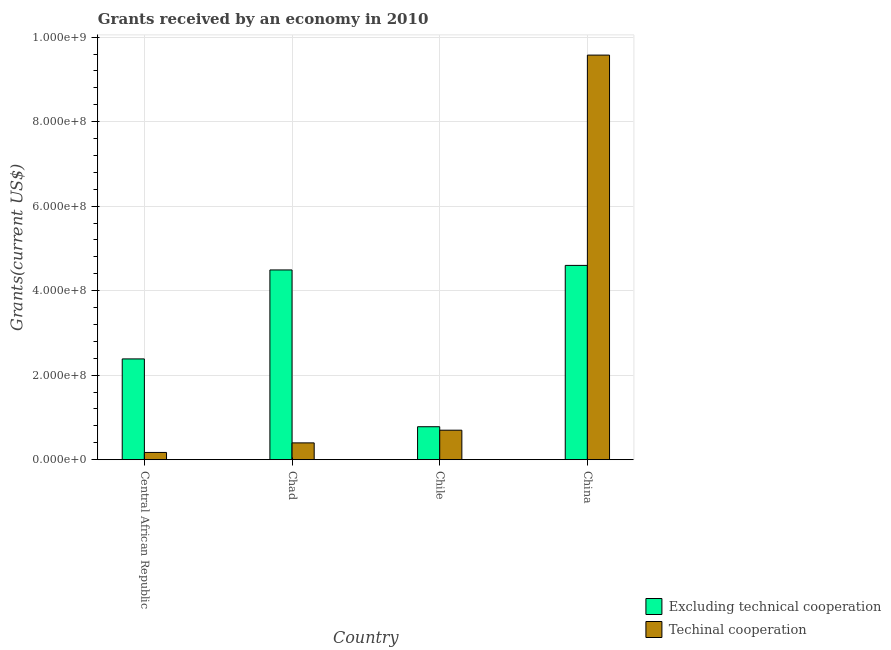How many different coloured bars are there?
Your response must be concise. 2. How many groups of bars are there?
Provide a short and direct response. 4. Are the number of bars per tick equal to the number of legend labels?
Provide a short and direct response. Yes. How many bars are there on the 3rd tick from the left?
Offer a very short reply. 2. What is the label of the 2nd group of bars from the left?
Keep it short and to the point. Chad. In how many cases, is the number of bars for a given country not equal to the number of legend labels?
Give a very brief answer. 0. What is the amount of grants received(including technical cooperation) in Central African Republic?
Provide a short and direct response. 1.72e+07. Across all countries, what is the maximum amount of grants received(excluding technical cooperation)?
Your answer should be very brief. 4.60e+08. Across all countries, what is the minimum amount of grants received(excluding technical cooperation)?
Your response must be concise. 7.80e+07. In which country was the amount of grants received(including technical cooperation) maximum?
Offer a terse response. China. In which country was the amount of grants received(including technical cooperation) minimum?
Your answer should be compact. Central African Republic. What is the total amount of grants received(excluding technical cooperation) in the graph?
Make the answer very short. 1.23e+09. What is the difference between the amount of grants received(excluding technical cooperation) in Central African Republic and that in Chile?
Provide a short and direct response. 1.60e+08. What is the difference between the amount of grants received(including technical cooperation) in China and the amount of grants received(excluding technical cooperation) in Chile?
Your response must be concise. 8.79e+08. What is the average amount of grants received(including technical cooperation) per country?
Your answer should be very brief. 2.71e+08. What is the difference between the amount of grants received(including technical cooperation) and amount of grants received(excluding technical cooperation) in Central African Republic?
Provide a succinct answer. -2.21e+08. In how many countries, is the amount of grants received(including technical cooperation) greater than 520000000 US$?
Your answer should be very brief. 1. What is the ratio of the amount of grants received(including technical cooperation) in Chad to that in Chile?
Your answer should be very brief. 0.57. Is the amount of grants received(excluding technical cooperation) in Chile less than that in China?
Your answer should be compact. Yes. Is the difference between the amount of grants received(including technical cooperation) in Central African Republic and China greater than the difference between the amount of grants received(excluding technical cooperation) in Central African Republic and China?
Make the answer very short. No. What is the difference between the highest and the second highest amount of grants received(including technical cooperation)?
Keep it short and to the point. 8.88e+08. What is the difference between the highest and the lowest amount of grants received(including technical cooperation)?
Your answer should be very brief. 9.40e+08. What does the 1st bar from the left in China represents?
Provide a succinct answer. Excluding technical cooperation. What does the 1st bar from the right in China represents?
Offer a terse response. Techinal cooperation. How many bars are there?
Make the answer very short. 8. How many countries are there in the graph?
Provide a succinct answer. 4. Are the values on the major ticks of Y-axis written in scientific E-notation?
Your answer should be very brief. Yes. How are the legend labels stacked?
Give a very brief answer. Vertical. What is the title of the graph?
Offer a terse response. Grants received by an economy in 2010. Does "Transport services" appear as one of the legend labels in the graph?
Keep it short and to the point. No. What is the label or title of the X-axis?
Keep it short and to the point. Country. What is the label or title of the Y-axis?
Offer a terse response. Grants(current US$). What is the Grants(current US$) of Excluding technical cooperation in Central African Republic?
Your response must be concise. 2.38e+08. What is the Grants(current US$) in Techinal cooperation in Central African Republic?
Keep it short and to the point. 1.72e+07. What is the Grants(current US$) of Excluding technical cooperation in Chad?
Offer a terse response. 4.49e+08. What is the Grants(current US$) in Techinal cooperation in Chad?
Make the answer very short. 3.98e+07. What is the Grants(current US$) of Excluding technical cooperation in Chile?
Provide a succinct answer. 7.80e+07. What is the Grants(current US$) in Techinal cooperation in Chile?
Offer a terse response. 6.98e+07. What is the Grants(current US$) of Excluding technical cooperation in China?
Your answer should be compact. 4.60e+08. What is the Grants(current US$) of Techinal cooperation in China?
Provide a succinct answer. 9.57e+08. Across all countries, what is the maximum Grants(current US$) of Excluding technical cooperation?
Offer a terse response. 4.60e+08. Across all countries, what is the maximum Grants(current US$) in Techinal cooperation?
Your answer should be very brief. 9.57e+08. Across all countries, what is the minimum Grants(current US$) of Excluding technical cooperation?
Your answer should be compact. 7.80e+07. Across all countries, what is the minimum Grants(current US$) in Techinal cooperation?
Provide a short and direct response. 1.72e+07. What is the total Grants(current US$) of Excluding technical cooperation in the graph?
Provide a succinct answer. 1.23e+09. What is the total Grants(current US$) in Techinal cooperation in the graph?
Keep it short and to the point. 1.08e+09. What is the difference between the Grants(current US$) in Excluding technical cooperation in Central African Republic and that in Chad?
Give a very brief answer. -2.11e+08. What is the difference between the Grants(current US$) of Techinal cooperation in Central African Republic and that in Chad?
Your answer should be very brief. -2.26e+07. What is the difference between the Grants(current US$) in Excluding technical cooperation in Central African Republic and that in Chile?
Your response must be concise. 1.60e+08. What is the difference between the Grants(current US$) of Techinal cooperation in Central African Republic and that in Chile?
Offer a terse response. -5.27e+07. What is the difference between the Grants(current US$) of Excluding technical cooperation in Central African Republic and that in China?
Your answer should be compact. -2.21e+08. What is the difference between the Grants(current US$) of Techinal cooperation in Central African Republic and that in China?
Your answer should be compact. -9.40e+08. What is the difference between the Grants(current US$) in Excluding technical cooperation in Chad and that in Chile?
Ensure brevity in your answer.  3.71e+08. What is the difference between the Grants(current US$) of Techinal cooperation in Chad and that in Chile?
Provide a short and direct response. -3.00e+07. What is the difference between the Grants(current US$) in Excluding technical cooperation in Chad and that in China?
Provide a succinct answer. -1.08e+07. What is the difference between the Grants(current US$) in Techinal cooperation in Chad and that in China?
Give a very brief answer. -9.18e+08. What is the difference between the Grants(current US$) of Excluding technical cooperation in Chile and that in China?
Make the answer very short. -3.82e+08. What is the difference between the Grants(current US$) of Techinal cooperation in Chile and that in China?
Offer a terse response. -8.88e+08. What is the difference between the Grants(current US$) of Excluding technical cooperation in Central African Republic and the Grants(current US$) of Techinal cooperation in Chad?
Your answer should be very brief. 1.99e+08. What is the difference between the Grants(current US$) in Excluding technical cooperation in Central African Republic and the Grants(current US$) in Techinal cooperation in Chile?
Give a very brief answer. 1.69e+08. What is the difference between the Grants(current US$) in Excluding technical cooperation in Central African Republic and the Grants(current US$) in Techinal cooperation in China?
Provide a short and direct response. -7.19e+08. What is the difference between the Grants(current US$) of Excluding technical cooperation in Chad and the Grants(current US$) of Techinal cooperation in Chile?
Your answer should be very brief. 3.79e+08. What is the difference between the Grants(current US$) of Excluding technical cooperation in Chad and the Grants(current US$) of Techinal cooperation in China?
Provide a succinct answer. -5.08e+08. What is the difference between the Grants(current US$) in Excluding technical cooperation in Chile and the Grants(current US$) in Techinal cooperation in China?
Your answer should be compact. -8.79e+08. What is the average Grants(current US$) of Excluding technical cooperation per country?
Provide a short and direct response. 3.06e+08. What is the average Grants(current US$) in Techinal cooperation per country?
Your response must be concise. 2.71e+08. What is the difference between the Grants(current US$) of Excluding technical cooperation and Grants(current US$) of Techinal cooperation in Central African Republic?
Provide a succinct answer. 2.21e+08. What is the difference between the Grants(current US$) of Excluding technical cooperation and Grants(current US$) of Techinal cooperation in Chad?
Your answer should be compact. 4.09e+08. What is the difference between the Grants(current US$) of Excluding technical cooperation and Grants(current US$) of Techinal cooperation in Chile?
Your response must be concise. 8.22e+06. What is the difference between the Grants(current US$) in Excluding technical cooperation and Grants(current US$) in Techinal cooperation in China?
Make the answer very short. -4.98e+08. What is the ratio of the Grants(current US$) of Excluding technical cooperation in Central African Republic to that in Chad?
Give a very brief answer. 0.53. What is the ratio of the Grants(current US$) of Techinal cooperation in Central African Republic to that in Chad?
Offer a terse response. 0.43. What is the ratio of the Grants(current US$) of Excluding technical cooperation in Central African Republic to that in Chile?
Your response must be concise. 3.06. What is the ratio of the Grants(current US$) in Techinal cooperation in Central African Republic to that in Chile?
Your answer should be very brief. 0.25. What is the ratio of the Grants(current US$) of Excluding technical cooperation in Central African Republic to that in China?
Your answer should be very brief. 0.52. What is the ratio of the Grants(current US$) of Techinal cooperation in Central African Republic to that in China?
Provide a short and direct response. 0.02. What is the ratio of the Grants(current US$) in Excluding technical cooperation in Chad to that in Chile?
Your answer should be compact. 5.75. What is the ratio of the Grants(current US$) in Techinal cooperation in Chad to that in Chile?
Provide a short and direct response. 0.57. What is the ratio of the Grants(current US$) in Excluding technical cooperation in Chad to that in China?
Keep it short and to the point. 0.98. What is the ratio of the Grants(current US$) of Techinal cooperation in Chad to that in China?
Give a very brief answer. 0.04. What is the ratio of the Grants(current US$) in Excluding technical cooperation in Chile to that in China?
Give a very brief answer. 0.17. What is the ratio of the Grants(current US$) of Techinal cooperation in Chile to that in China?
Provide a succinct answer. 0.07. What is the difference between the highest and the second highest Grants(current US$) of Excluding technical cooperation?
Make the answer very short. 1.08e+07. What is the difference between the highest and the second highest Grants(current US$) of Techinal cooperation?
Your response must be concise. 8.88e+08. What is the difference between the highest and the lowest Grants(current US$) in Excluding technical cooperation?
Provide a succinct answer. 3.82e+08. What is the difference between the highest and the lowest Grants(current US$) of Techinal cooperation?
Make the answer very short. 9.40e+08. 